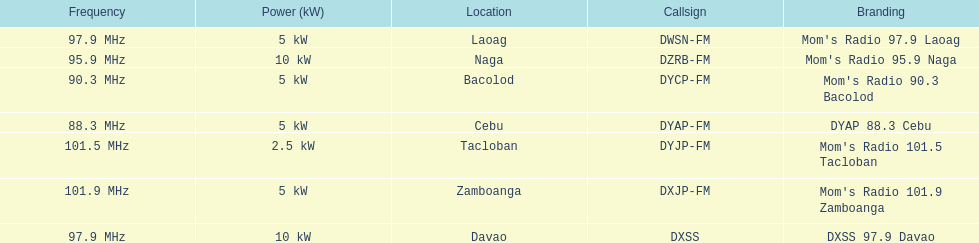What are the frequencies for radios of dyap-fm? 97.9 MHz, 95.9 MHz, 90.3 MHz, 88.3 MHz, 101.5 MHz, 101.9 MHz, 97.9 MHz. Parse the full table. {'header': ['Frequency', 'Power (kW)', 'Location', 'Callsign', 'Branding'], 'rows': [['97.9\xa0MHz', '5\xa0kW', 'Laoag', 'DWSN-FM', "Mom's Radio 97.9 Laoag"], ['95.9\xa0MHz', '10\xa0kW', 'Naga', 'DZRB-FM', "Mom's Radio 95.9 Naga"], ['90.3\xa0MHz', '5\xa0kW', 'Bacolod', 'DYCP-FM', "Mom's Radio 90.3 Bacolod"], ['88.3\xa0MHz', '5\xa0kW', 'Cebu', 'DYAP-FM', 'DYAP 88.3 Cebu'], ['101.5\xa0MHz', '2.5\xa0kW', 'Tacloban', 'DYJP-FM', "Mom's Radio 101.5 Tacloban"], ['101.9\xa0MHz', '5\xa0kW', 'Zamboanga', 'DXJP-FM', "Mom's Radio 101.9 Zamboanga"], ['97.9\xa0MHz', '10\xa0kW', 'Davao', 'DXSS', 'DXSS 97.9 Davao']]} What is the lowest frequency? 88.3 MHz. Which radio has this frequency? DYAP 88.3 Cebu. 